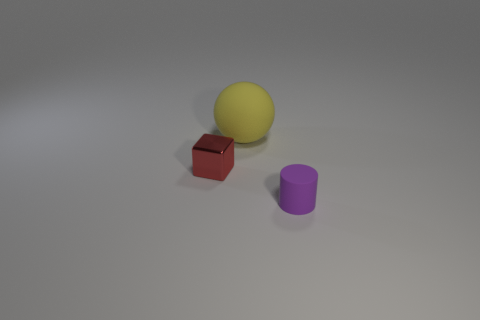Add 3 tiny green cylinders. How many objects exist? 6 Subtract all blocks. How many objects are left? 2 Add 2 small red things. How many small red things exist? 3 Subtract 0 brown cylinders. How many objects are left? 3 Subtract all tiny blue things. Subtract all metallic blocks. How many objects are left? 2 Add 1 tiny purple cylinders. How many tiny purple cylinders are left? 2 